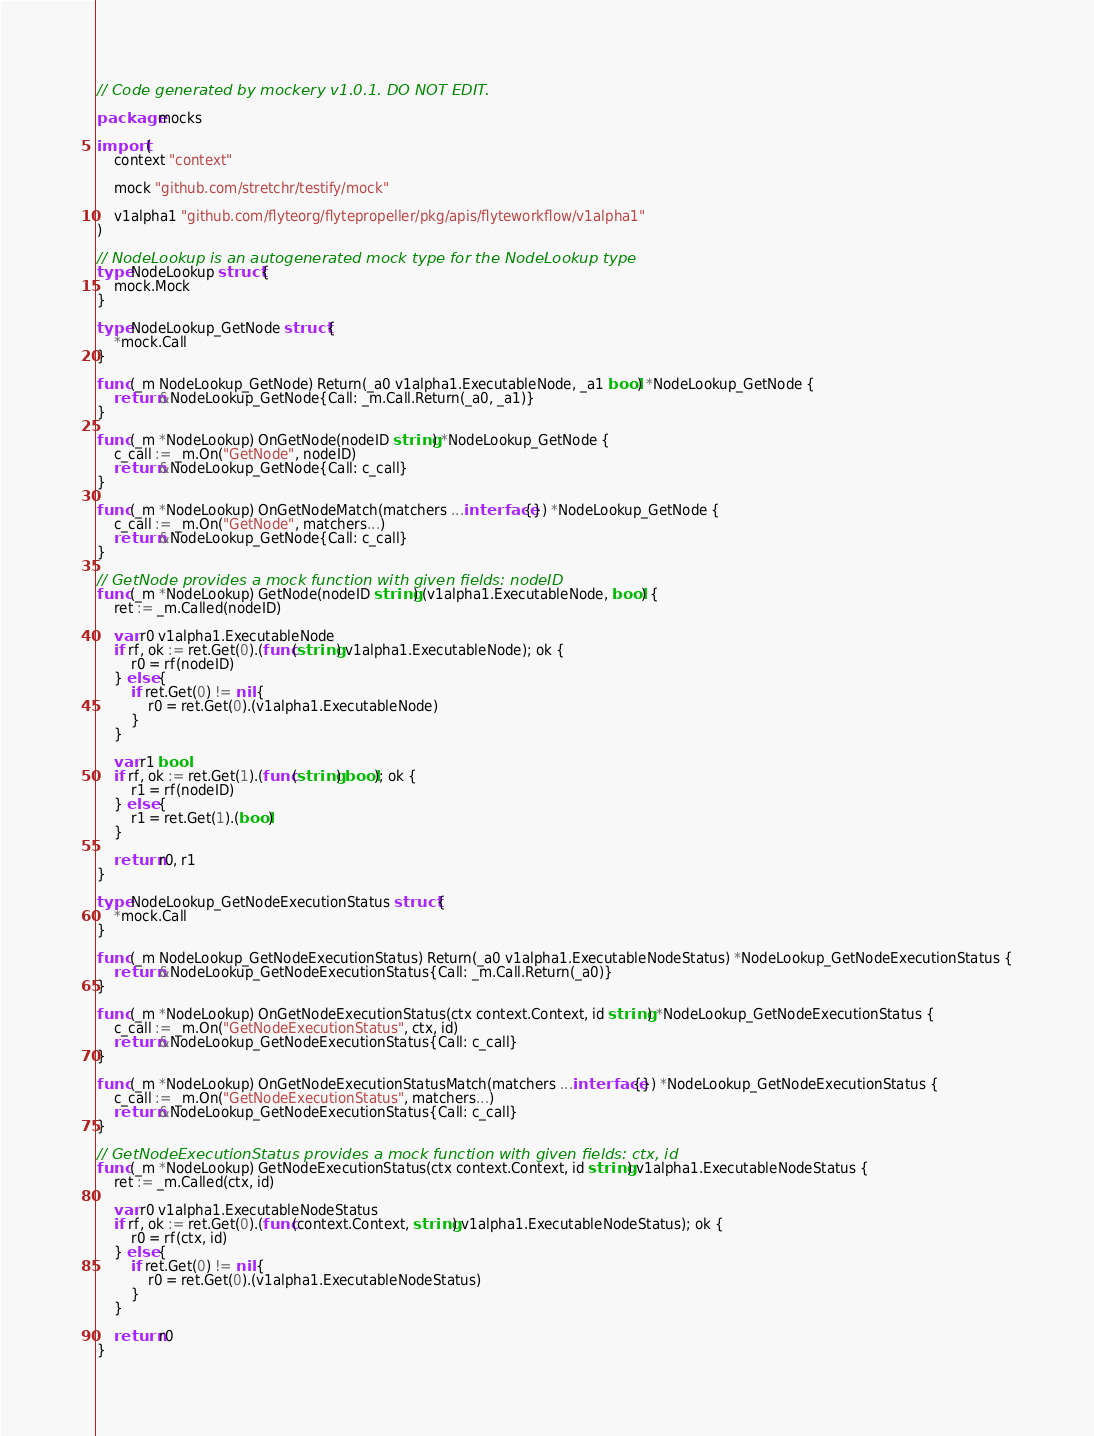Convert code to text. <code><loc_0><loc_0><loc_500><loc_500><_Go_>// Code generated by mockery v1.0.1. DO NOT EDIT.

package mocks

import (
	context "context"

	mock "github.com/stretchr/testify/mock"

	v1alpha1 "github.com/flyteorg/flytepropeller/pkg/apis/flyteworkflow/v1alpha1"
)

// NodeLookup is an autogenerated mock type for the NodeLookup type
type NodeLookup struct {
	mock.Mock
}

type NodeLookup_GetNode struct {
	*mock.Call
}

func (_m NodeLookup_GetNode) Return(_a0 v1alpha1.ExecutableNode, _a1 bool) *NodeLookup_GetNode {
	return &NodeLookup_GetNode{Call: _m.Call.Return(_a0, _a1)}
}

func (_m *NodeLookup) OnGetNode(nodeID string) *NodeLookup_GetNode {
	c_call := _m.On("GetNode", nodeID)
	return &NodeLookup_GetNode{Call: c_call}
}

func (_m *NodeLookup) OnGetNodeMatch(matchers ...interface{}) *NodeLookup_GetNode {
	c_call := _m.On("GetNode", matchers...)
	return &NodeLookup_GetNode{Call: c_call}
}

// GetNode provides a mock function with given fields: nodeID
func (_m *NodeLookup) GetNode(nodeID string) (v1alpha1.ExecutableNode, bool) {
	ret := _m.Called(nodeID)

	var r0 v1alpha1.ExecutableNode
	if rf, ok := ret.Get(0).(func(string) v1alpha1.ExecutableNode); ok {
		r0 = rf(nodeID)
	} else {
		if ret.Get(0) != nil {
			r0 = ret.Get(0).(v1alpha1.ExecutableNode)
		}
	}

	var r1 bool
	if rf, ok := ret.Get(1).(func(string) bool); ok {
		r1 = rf(nodeID)
	} else {
		r1 = ret.Get(1).(bool)
	}

	return r0, r1
}

type NodeLookup_GetNodeExecutionStatus struct {
	*mock.Call
}

func (_m NodeLookup_GetNodeExecutionStatus) Return(_a0 v1alpha1.ExecutableNodeStatus) *NodeLookup_GetNodeExecutionStatus {
	return &NodeLookup_GetNodeExecutionStatus{Call: _m.Call.Return(_a0)}
}

func (_m *NodeLookup) OnGetNodeExecutionStatus(ctx context.Context, id string) *NodeLookup_GetNodeExecutionStatus {
	c_call := _m.On("GetNodeExecutionStatus", ctx, id)
	return &NodeLookup_GetNodeExecutionStatus{Call: c_call}
}

func (_m *NodeLookup) OnGetNodeExecutionStatusMatch(matchers ...interface{}) *NodeLookup_GetNodeExecutionStatus {
	c_call := _m.On("GetNodeExecutionStatus", matchers...)
	return &NodeLookup_GetNodeExecutionStatus{Call: c_call}
}

// GetNodeExecutionStatus provides a mock function with given fields: ctx, id
func (_m *NodeLookup) GetNodeExecutionStatus(ctx context.Context, id string) v1alpha1.ExecutableNodeStatus {
	ret := _m.Called(ctx, id)

	var r0 v1alpha1.ExecutableNodeStatus
	if rf, ok := ret.Get(0).(func(context.Context, string) v1alpha1.ExecutableNodeStatus); ok {
		r0 = rf(ctx, id)
	} else {
		if ret.Get(0) != nil {
			r0 = ret.Get(0).(v1alpha1.ExecutableNodeStatus)
		}
	}

	return r0
}
</code> 